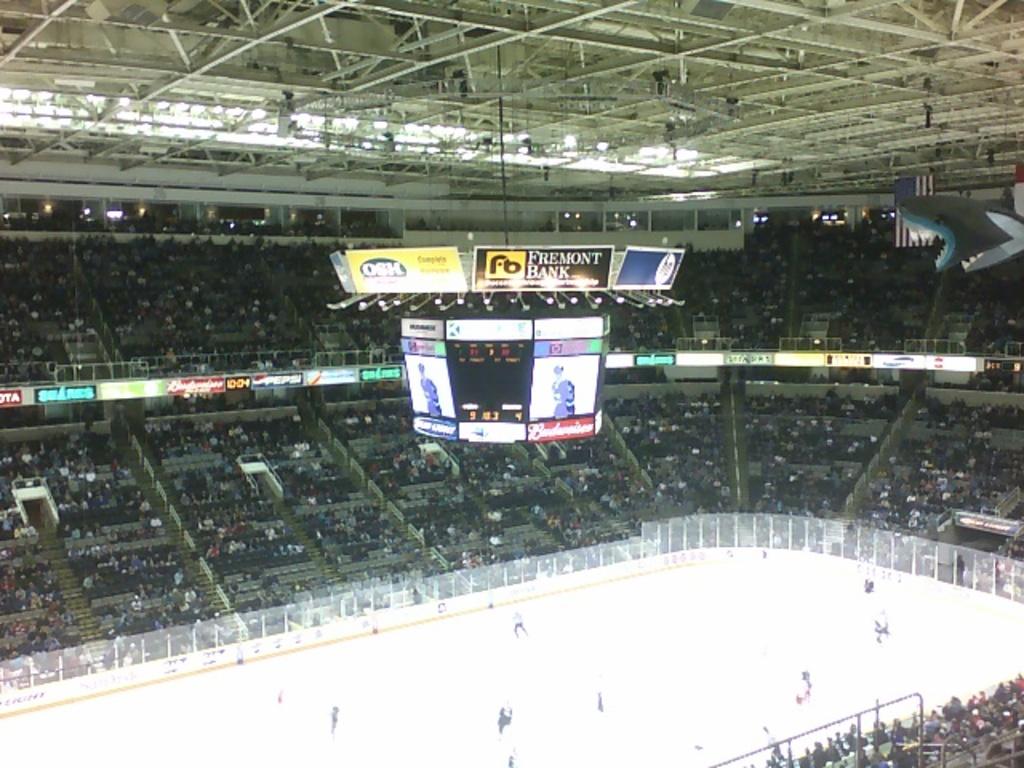What is one of the brands listed on or near the scoreboard?
Provide a short and direct response. Fremont bank. What kind of beer is on the bottom?
Offer a terse response. Budweiser. 